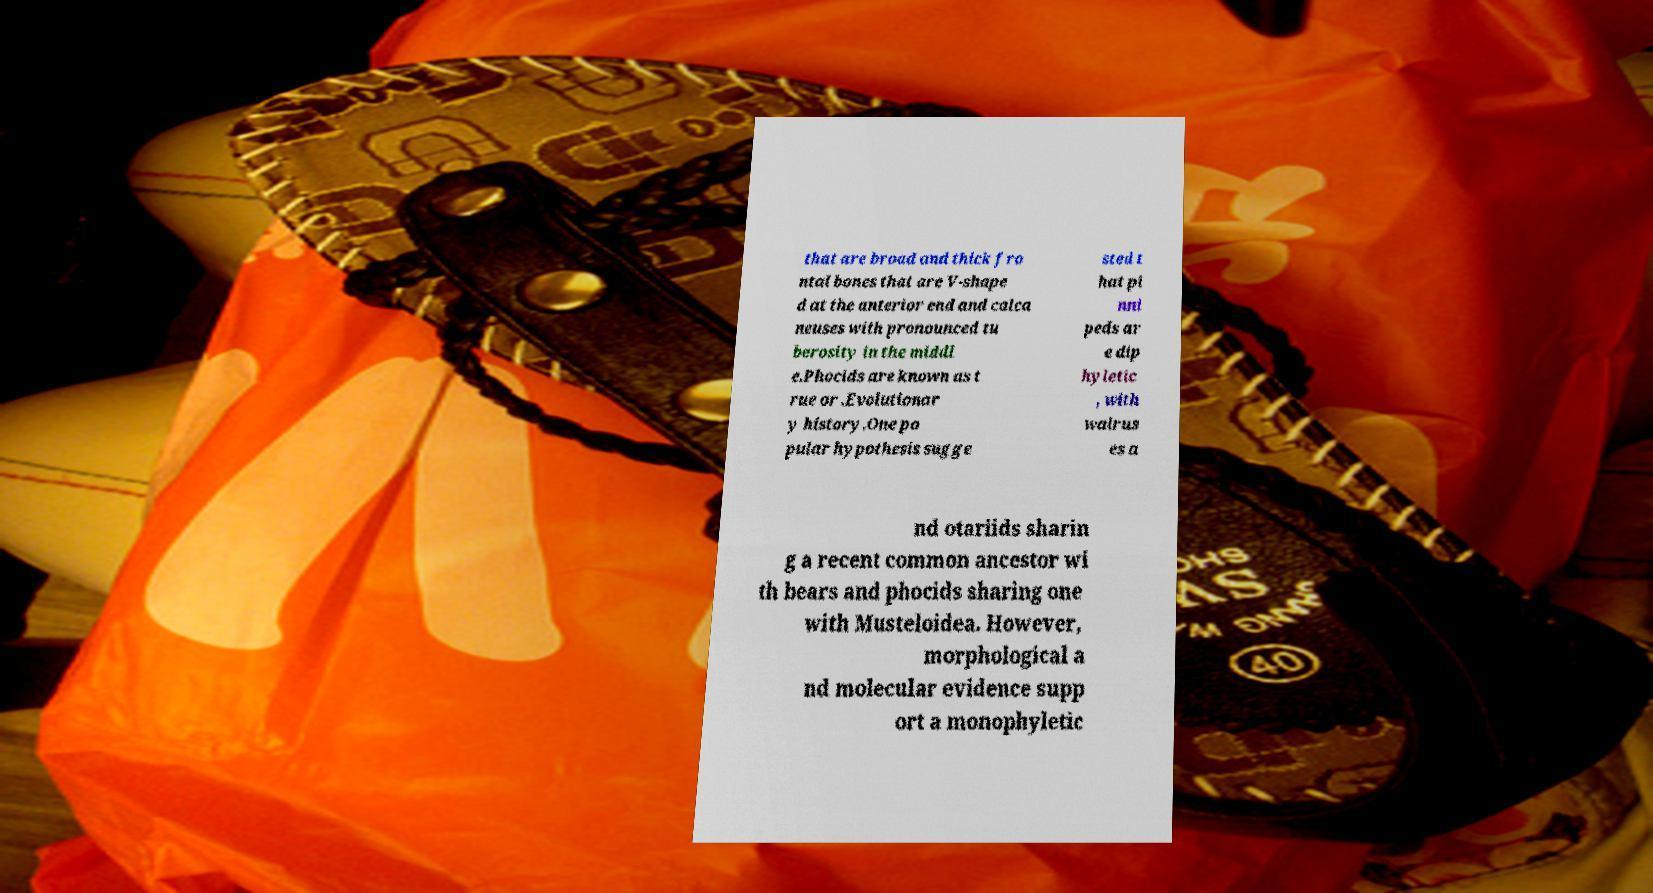What messages or text are displayed in this image? I need them in a readable, typed format. that are broad and thick fro ntal bones that are V-shape d at the anterior end and calca neuses with pronounced tu berosity in the middl e.Phocids are known as t rue or .Evolutionar y history.One po pular hypothesis sugge sted t hat pi nni peds ar e dip hyletic , with walrus es a nd otariids sharin g a recent common ancestor wi th bears and phocids sharing one with Musteloidea. However, morphological a nd molecular evidence supp ort a monophyletic 